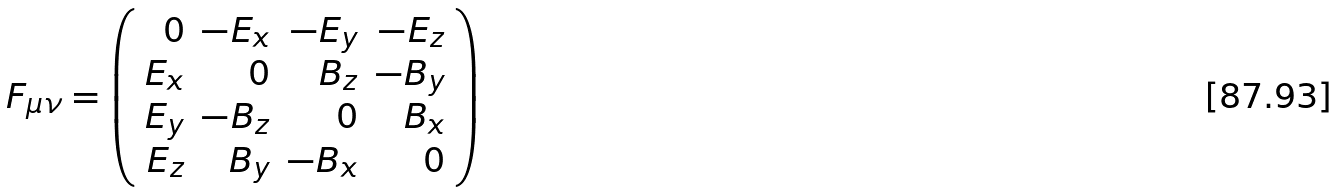<formula> <loc_0><loc_0><loc_500><loc_500>F _ { \mu \nu } = \left ( \begin{array} { r r r r } 0 & - E _ { x } & - E _ { y } & - E _ { z } \\ E _ { x } & 0 & B _ { z } & - B _ { y } \\ E _ { y } & - B _ { z } & 0 & B _ { x } \\ E _ { z } & B _ { y } & - B _ { x } & 0 \end{array} \right )</formula> 